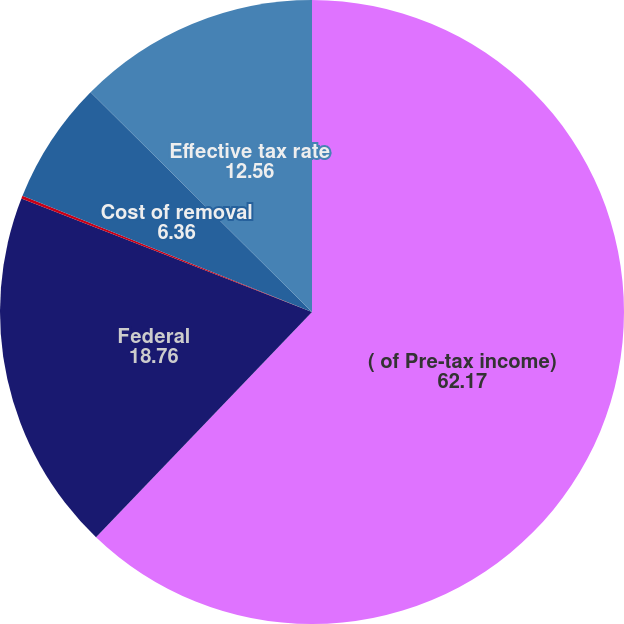Convert chart to OTSL. <chart><loc_0><loc_0><loc_500><loc_500><pie_chart><fcel>( of Pre-tax income)<fcel>Federal<fcel>State income tax<fcel>Cost of removal<fcel>Effective tax rate<nl><fcel>62.17%<fcel>18.76%<fcel>0.15%<fcel>6.36%<fcel>12.56%<nl></chart> 